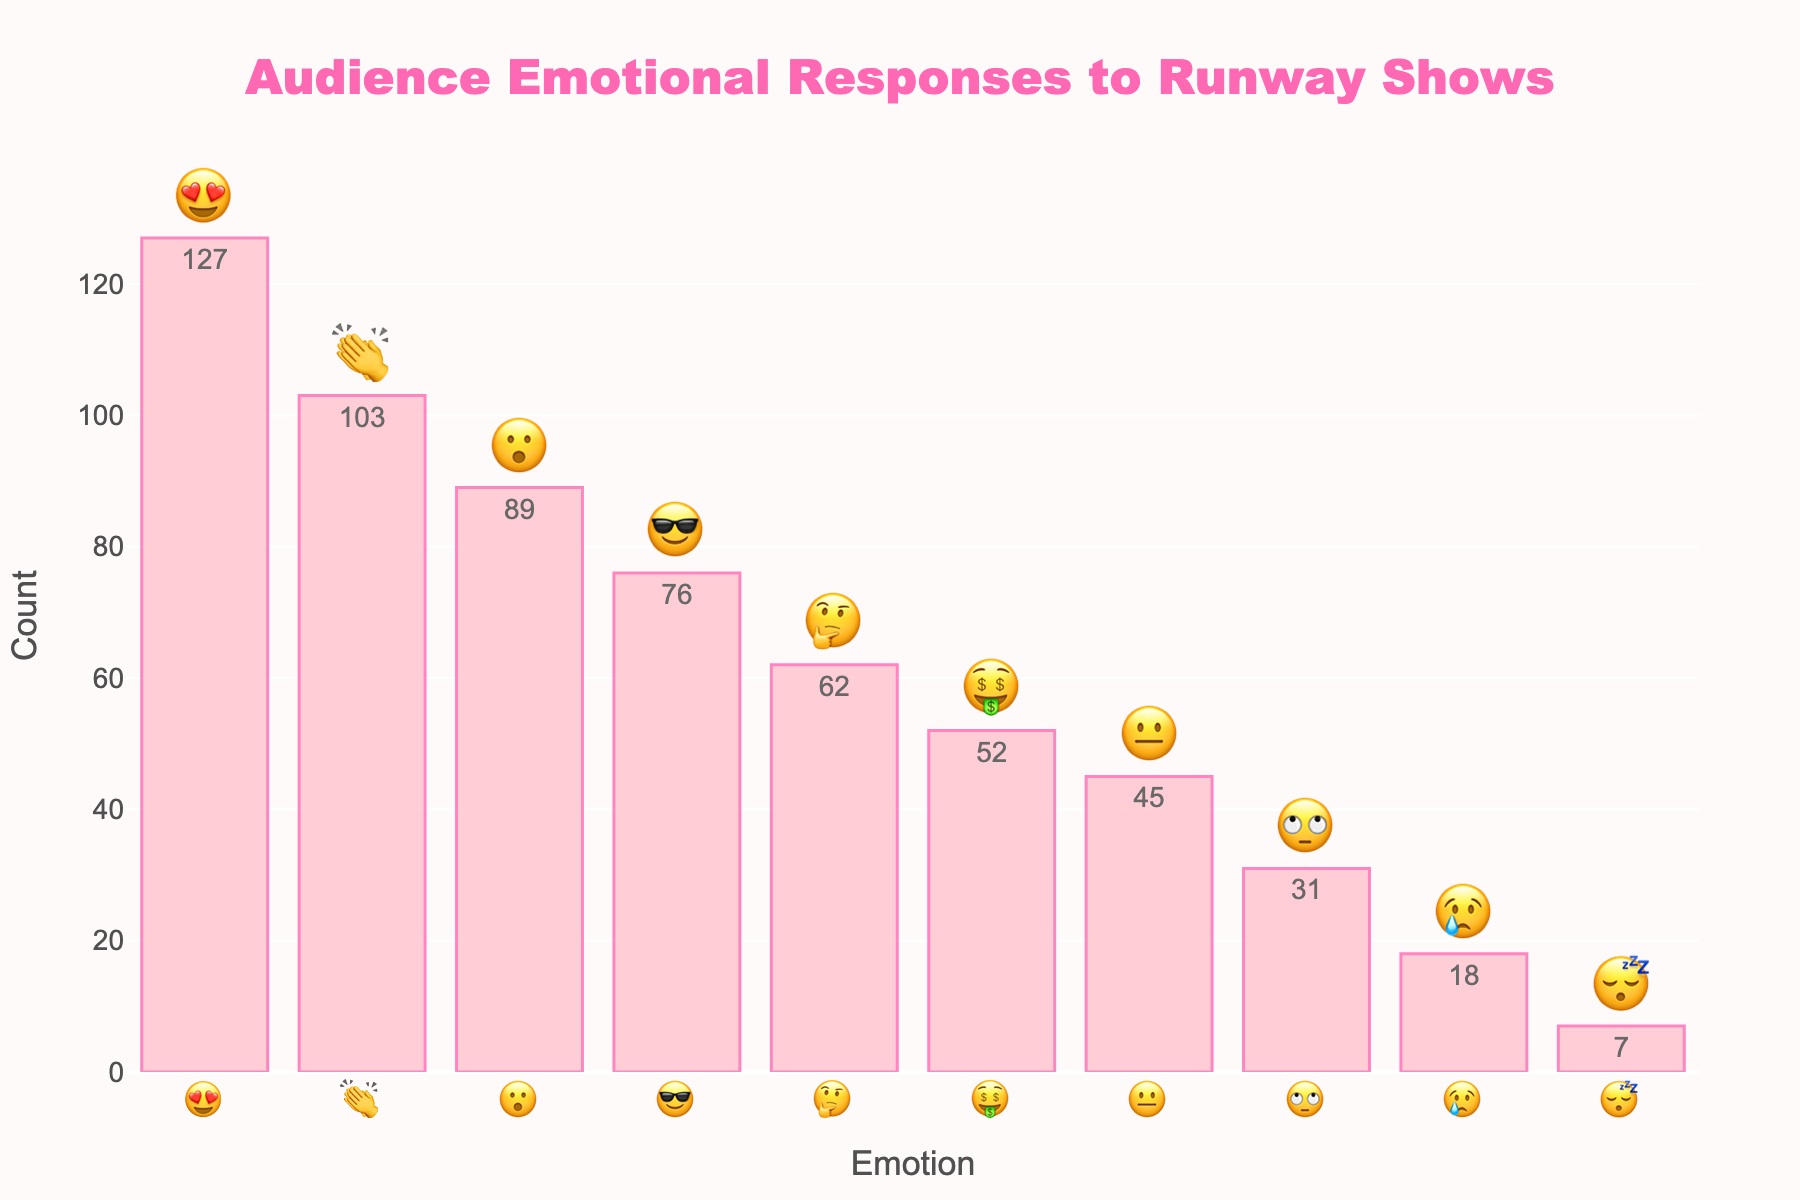What's the most common emotional response? First, look at the title of the chart, which indicates it's about "Audience Emotional Responses to Runway Shows." Then, check the bars and the corresponding counts to find the highest one. "😍" has the highest count of 127.
Answer: 😍 What emotion had the lowest count, and what was that count? Find the shortest bar in the chart, which corresponds to the lowest count. The emotion attached to it is "😴" with a count of 7.
Answer: 😴, 7 How many emotions have a count greater than 50? Count the bars whose heights correspond to counts greater than 50. These emotions are "😍, 😮, 👏, 🤑, 😎" totaling five emotions.
Answer: 5 Which two emotions have the highest counts? Identify the two tallest bars. They correspond to "😍" with a count of 127 and "👏" with a count of 103.
Answer: 😍 and 👏 What's the difference in counts between the "😍" and "😮" emotions? The count for "😍" is 127 and for "😮" is 89. Subtract the smaller count from the larger one: 127 - 89 = 38.
Answer: 38 How many total emotions are represented in the chart? Count the distinct emojis along the x-axis to get the total number of emotions. There are 10 distinct emotions.
Answer: 10 What is the average count of the emotions? Add up all the counts and divide by the number of emotions (10): (127 + 89 + 62 + 45 + 18 + 31 + 103 + 7 + 52 + 76) / 10 = 610 / 10 = 61.
Answer: 61 Which emotion is more common, "🤔" or "😢"? Compare the heights of the bars for "🤔" and "😢." "🤔" has a count of 62, and "😢" has a count of 18. So, "🤔" is more common.
Answer: 🤔 What is the combined count for "👏" and "😍" emotions? Add the counts for "👏" and "😍." The counts are 103 and 127 respectively. 103 + 127 = 230.
Answer: 230 